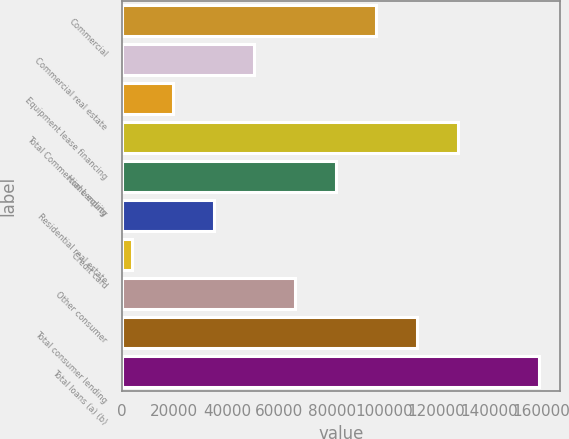Convert chart to OTSL. <chart><loc_0><loc_0><loc_500><loc_500><bar_chart><fcel>Commercial<fcel>Commercial real estate<fcel>Equipment lease financing<fcel>Total Commercial Lending<fcel>Home equity<fcel>Residential real estate<fcel>Credit card<fcel>Other consumer<fcel>Total consumer lending<fcel>Total loans (a) (b)<nl><fcel>96998.8<fcel>50487.4<fcel>19479.8<fcel>128006<fcel>81495<fcel>34983.6<fcel>3976<fcel>65991.2<fcel>112503<fcel>159014<nl></chart> 